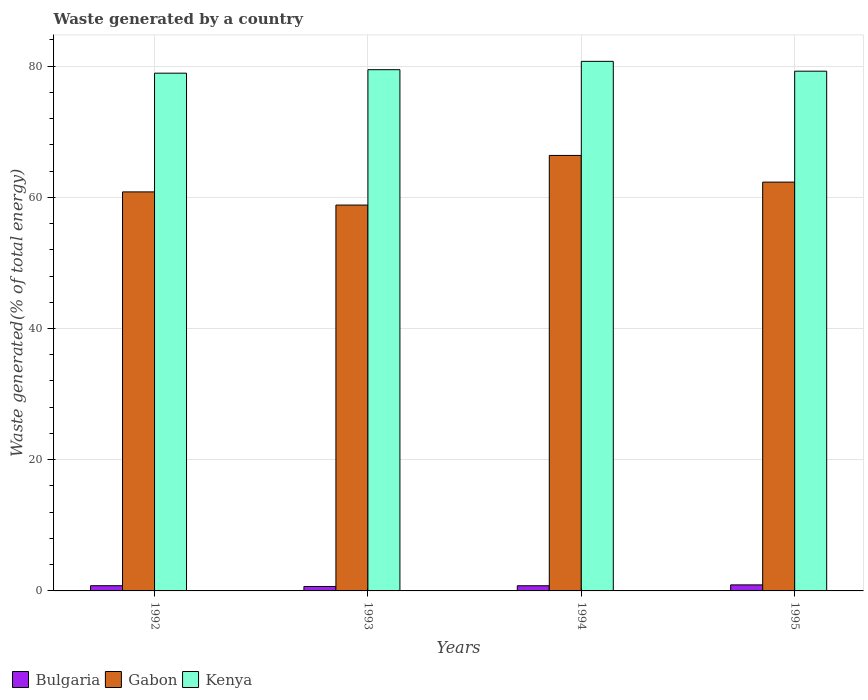How many groups of bars are there?
Provide a succinct answer. 4. Are the number of bars per tick equal to the number of legend labels?
Provide a succinct answer. Yes. How many bars are there on the 4th tick from the right?
Provide a succinct answer. 3. What is the label of the 4th group of bars from the left?
Your answer should be compact. 1995. In how many cases, is the number of bars for a given year not equal to the number of legend labels?
Ensure brevity in your answer.  0. What is the total waste generated in Kenya in 1995?
Offer a terse response. 79.23. Across all years, what is the maximum total waste generated in Gabon?
Give a very brief answer. 66.38. Across all years, what is the minimum total waste generated in Gabon?
Ensure brevity in your answer.  58.82. In which year was the total waste generated in Bulgaria maximum?
Provide a succinct answer. 1995. In which year was the total waste generated in Bulgaria minimum?
Give a very brief answer. 1993. What is the total total waste generated in Kenya in the graph?
Your answer should be compact. 318.33. What is the difference between the total waste generated in Kenya in 1993 and that in 1995?
Your answer should be compact. 0.23. What is the difference between the total waste generated in Gabon in 1992 and the total waste generated in Bulgaria in 1994?
Your response must be concise. 60.04. What is the average total waste generated in Kenya per year?
Provide a succinct answer. 79.58. In the year 1994, what is the difference between the total waste generated in Kenya and total waste generated in Bulgaria?
Offer a terse response. 79.94. What is the ratio of the total waste generated in Gabon in 1992 to that in 1994?
Offer a terse response. 0.92. Is the total waste generated in Kenya in 1993 less than that in 1994?
Offer a terse response. Yes. Is the difference between the total waste generated in Kenya in 1992 and 1994 greater than the difference between the total waste generated in Bulgaria in 1992 and 1994?
Your response must be concise. No. What is the difference between the highest and the second highest total waste generated in Kenya?
Ensure brevity in your answer.  1.27. What is the difference between the highest and the lowest total waste generated in Kenya?
Offer a terse response. 1.8. Is the sum of the total waste generated in Bulgaria in 1993 and 1995 greater than the maximum total waste generated in Kenya across all years?
Make the answer very short. No. What does the 2nd bar from the left in 1995 represents?
Offer a very short reply. Gabon. What does the 1st bar from the right in 1994 represents?
Ensure brevity in your answer.  Kenya. What is the difference between two consecutive major ticks on the Y-axis?
Ensure brevity in your answer.  20. Are the values on the major ticks of Y-axis written in scientific E-notation?
Your response must be concise. No. Does the graph contain any zero values?
Give a very brief answer. No. How are the legend labels stacked?
Your answer should be compact. Horizontal. What is the title of the graph?
Your answer should be very brief. Waste generated by a country. Does "Turkey" appear as one of the legend labels in the graph?
Make the answer very short. No. What is the label or title of the X-axis?
Provide a short and direct response. Years. What is the label or title of the Y-axis?
Offer a very short reply. Waste generated(% of total energy). What is the Waste generated(% of total energy) in Bulgaria in 1992?
Make the answer very short. 0.79. What is the Waste generated(% of total energy) in Gabon in 1992?
Provide a short and direct response. 60.83. What is the Waste generated(% of total energy) of Kenya in 1992?
Your answer should be very brief. 78.92. What is the Waste generated(% of total energy) of Bulgaria in 1993?
Make the answer very short. 0.68. What is the Waste generated(% of total energy) in Gabon in 1993?
Your response must be concise. 58.82. What is the Waste generated(% of total energy) of Kenya in 1993?
Your answer should be very brief. 79.45. What is the Waste generated(% of total energy) in Bulgaria in 1994?
Your answer should be compact. 0.79. What is the Waste generated(% of total energy) in Gabon in 1994?
Provide a short and direct response. 66.38. What is the Waste generated(% of total energy) in Kenya in 1994?
Ensure brevity in your answer.  80.73. What is the Waste generated(% of total energy) in Bulgaria in 1995?
Ensure brevity in your answer.  0.92. What is the Waste generated(% of total energy) of Gabon in 1995?
Offer a terse response. 62.32. What is the Waste generated(% of total energy) of Kenya in 1995?
Offer a very short reply. 79.23. Across all years, what is the maximum Waste generated(% of total energy) of Bulgaria?
Your response must be concise. 0.92. Across all years, what is the maximum Waste generated(% of total energy) in Gabon?
Offer a very short reply. 66.38. Across all years, what is the maximum Waste generated(% of total energy) of Kenya?
Offer a terse response. 80.73. Across all years, what is the minimum Waste generated(% of total energy) in Bulgaria?
Your answer should be compact. 0.68. Across all years, what is the minimum Waste generated(% of total energy) of Gabon?
Your answer should be compact. 58.82. Across all years, what is the minimum Waste generated(% of total energy) in Kenya?
Offer a very short reply. 78.92. What is the total Waste generated(% of total energy) of Bulgaria in the graph?
Make the answer very short. 3.18. What is the total Waste generated(% of total energy) in Gabon in the graph?
Offer a terse response. 248.34. What is the total Waste generated(% of total energy) in Kenya in the graph?
Ensure brevity in your answer.  318.33. What is the difference between the Waste generated(% of total energy) in Bulgaria in 1992 and that in 1993?
Your response must be concise. 0.12. What is the difference between the Waste generated(% of total energy) of Gabon in 1992 and that in 1993?
Your response must be concise. 2.01. What is the difference between the Waste generated(% of total energy) in Kenya in 1992 and that in 1993?
Offer a terse response. -0.53. What is the difference between the Waste generated(% of total energy) of Bulgaria in 1992 and that in 1994?
Provide a short and direct response. 0.01. What is the difference between the Waste generated(% of total energy) of Gabon in 1992 and that in 1994?
Your response must be concise. -5.56. What is the difference between the Waste generated(% of total energy) of Kenya in 1992 and that in 1994?
Provide a short and direct response. -1.8. What is the difference between the Waste generated(% of total energy) in Bulgaria in 1992 and that in 1995?
Offer a terse response. -0.13. What is the difference between the Waste generated(% of total energy) in Gabon in 1992 and that in 1995?
Make the answer very short. -1.49. What is the difference between the Waste generated(% of total energy) in Kenya in 1992 and that in 1995?
Provide a short and direct response. -0.3. What is the difference between the Waste generated(% of total energy) in Bulgaria in 1993 and that in 1994?
Keep it short and to the point. -0.11. What is the difference between the Waste generated(% of total energy) of Gabon in 1993 and that in 1994?
Keep it short and to the point. -7.57. What is the difference between the Waste generated(% of total energy) in Kenya in 1993 and that in 1994?
Keep it short and to the point. -1.27. What is the difference between the Waste generated(% of total energy) of Bulgaria in 1993 and that in 1995?
Ensure brevity in your answer.  -0.24. What is the difference between the Waste generated(% of total energy) in Gabon in 1993 and that in 1995?
Your response must be concise. -3.5. What is the difference between the Waste generated(% of total energy) of Kenya in 1993 and that in 1995?
Keep it short and to the point. 0.23. What is the difference between the Waste generated(% of total energy) of Bulgaria in 1994 and that in 1995?
Keep it short and to the point. -0.13. What is the difference between the Waste generated(% of total energy) in Gabon in 1994 and that in 1995?
Provide a short and direct response. 4.07. What is the difference between the Waste generated(% of total energy) in Kenya in 1994 and that in 1995?
Offer a very short reply. 1.5. What is the difference between the Waste generated(% of total energy) in Bulgaria in 1992 and the Waste generated(% of total energy) in Gabon in 1993?
Provide a succinct answer. -58.02. What is the difference between the Waste generated(% of total energy) in Bulgaria in 1992 and the Waste generated(% of total energy) in Kenya in 1993?
Ensure brevity in your answer.  -78.66. What is the difference between the Waste generated(% of total energy) in Gabon in 1992 and the Waste generated(% of total energy) in Kenya in 1993?
Provide a short and direct response. -18.63. What is the difference between the Waste generated(% of total energy) in Bulgaria in 1992 and the Waste generated(% of total energy) in Gabon in 1994?
Your answer should be compact. -65.59. What is the difference between the Waste generated(% of total energy) of Bulgaria in 1992 and the Waste generated(% of total energy) of Kenya in 1994?
Give a very brief answer. -79.93. What is the difference between the Waste generated(% of total energy) in Gabon in 1992 and the Waste generated(% of total energy) in Kenya in 1994?
Your answer should be compact. -19.9. What is the difference between the Waste generated(% of total energy) in Bulgaria in 1992 and the Waste generated(% of total energy) in Gabon in 1995?
Your answer should be compact. -61.52. What is the difference between the Waste generated(% of total energy) of Bulgaria in 1992 and the Waste generated(% of total energy) of Kenya in 1995?
Give a very brief answer. -78.43. What is the difference between the Waste generated(% of total energy) in Gabon in 1992 and the Waste generated(% of total energy) in Kenya in 1995?
Provide a succinct answer. -18.4. What is the difference between the Waste generated(% of total energy) of Bulgaria in 1993 and the Waste generated(% of total energy) of Gabon in 1994?
Your answer should be compact. -65.71. What is the difference between the Waste generated(% of total energy) of Bulgaria in 1993 and the Waste generated(% of total energy) of Kenya in 1994?
Provide a short and direct response. -80.05. What is the difference between the Waste generated(% of total energy) in Gabon in 1993 and the Waste generated(% of total energy) in Kenya in 1994?
Make the answer very short. -21.91. What is the difference between the Waste generated(% of total energy) of Bulgaria in 1993 and the Waste generated(% of total energy) of Gabon in 1995?
Give a very brief answer. -61.64. What is the difference between the Waste generated(% of total energy) in Bulgaria in 1993 and the Waste generated(% of total energy) in Kenya in 1995?
Keep it short and to the point. -78.55. What is the difference between the Waste generated(% of total energy) of Gabon in 1993 and the Waste generated(% of total energy) of Kenya in 1995?
Provide a succinct answer. -20.41. What is the difference between the Waste generated(% of total energy) in Bulgaria in 1994 and the Waste generated(% of total energy) in Gabon in 1995?
Your response must be concise. -61.53. What is the difference between the Waste generated(% of total energy) in Bulgaria in 1994 and the Waste generated(% of total energy) in Kenya in 1995?
Provide a succinct answer. -78.44. What is the difference between the Waste generated(% of total energy) of Gabon in 1994 and the Waste generated(% of total energy) of Kenya in 1995?
Provide a succinct answer. -12.84. What is the average Waste generated(% of total energy) in Bulgaria per year?
Your answer should be very brief. 0.79. What is the average Waste generated(% of total energy) of Gabon per year?
Your answer should be compact. 62.09. What is the average Waste generated(% of total energy) in Kenya per year?
Your answer should be very brief. 79.58. In the year 1992, what is the difference between the Waste generated(% of total energy) in Bulgaria and Waste generated(% of total energy) in Gabon?
Keep it short and to the point. -60.03. In the year 1992, what is the difference between the Waste generated(% of total energy) of Bulgaria and Waste generated(% of total energy) of Kenya?
Your answer should be very brief. -78.13. In the year 1992, what is the difference between the Waste generated(% of total energy) in Gabon and Waste generated(% of total energy) in Kenya?
Make the answer very short. -18.1. In the year 1993, what is the difference between the Waste generated(% of total energy) in Bulgaria and Waste generated(% of total energy) in Gabon?
Ensure brevity in your answer.  -58.14. In the year 1993, what is the difference between the Waste generated(% of total energy) in Bulgaria and Waste generated(% of total energy) in Kenya?
Give a very brief answer. -78.77. In the year 1993, what is the difference between the Waste generated(% of total energy) of Gabon and Waste generated(% of total energy) of Kenya?
Provide a succinct answer. -20.64. In the year 1994, what is the difference between the Waste generated(% of total energy) in Bulgaria and Waste generated(% of total energy) in Gabon?
Provide a succinct answer. -65.6. In the year 1994, what is the difference between the Waste generated(% of total energy) in Bulgaria and Waste generated(% of total energy) in Kenya?
Make the answer very short. -79.94. In the year 1994, what is the difference between the Waste generated(% of total energy) of Gabon and Waste generated(% of total energy) of Kenya?
Offer a very short reply. -14.34. In the year 1995, what is the difference between the Waste generated(% of total energy) of Bulgaria and Waste generated(% of total energy) of Gabon?
Your answer should be compact. -61.4. In the year 1995, what is the difference between the Waste generated(% of total energy) of Bulgaria and Waste generated(% of total energy) of Kenya?
Keep it short and to the point. -78.31. In the year 1995, what is the difference between the Waste generated(% of total energy) of Gabon and Waste generated(% of total energy) of Kenya?
Provide a succinct answer. -16.91. What is the ratio of the Waste generated(% of total energy) in Bulgaria in 1992 to that in 1993?
Offer a very short reply. 1.17. What is the ratio of the Waste generated(% of total energy) of Gabon in 1992 to that in 1993?
Keep it short and to the point. 1.03. What is the ratio of the Waste generated(% of total energy) of Kenya in 1992 to that in 1993?
Offer a terse response. 0.99. What is the ratio of the Waste generated(% of total energy) in Bulgaria in 1992 to that in 1994?
Your response must be concise. 1.01. What is the ratio of the Waste generated(% of total energy) of Gabon in 1992 to that in 1994?
Provide a short and direct response. 0.92. What is the ratio of the Waste generated(% of total energy) in Kenya in 1992 to that in 1994?
Keep it short and to the point. 0.98. What is the ratio of the Waste generated(% of total energy) in Bulgaria in 1992 to that in 1995?
Ensure brevity in your answer.  0.86. What is the ratio of the Waste generated(% of total energy) in Gabon in 1992 to that in 1995?
Your response must be concise. 0.98. What is the ratio of the Waste generated(% of total energy) of Bulgaria in 1993 to that in 1994?
Offer a terse response. 0.86. What is the ratio of the Waste generated(% of total energy) of Gabon in 1993 to that in 1994?
Give a very brief answer. 0.89. What is the ratio of the Waste generated(% of total energy) of Kenya in 1993 to that in 1994?
Offer a terse response. 0.98. What is the ratio of the Waste generated(% of total energy) of Bulgaria in 1993 to that in 1995?
Your answer should be very brief. 0.74. What is the ratio of the Waste generated(% of total energy) in Gabon in 1993 to that in 1995?
Your response must be concise. 0.94. What is the ratio of the Waste generated(% of total energy) of Bulgaria in 1994 to that in 1995?
Keep it short and to the point. 0.86. What is the ratio of the Waste generated(% of total energy) of Gabon in 1994 to that in 1995?
Keep it short and to the point. 1.07. What is the ratio of the Waste generated(% of total energy) of Kenya in 1994 to that in 1995?
Offer a terse response. 1.02. What is the difference between the highest and the second highest Waste generated(% of total energy) of Bulgaria?
Offer a terse response. 0.13. What is the difference between the highest and the second highest Waste generated(% of total energy) in Gabon?
Ensure brevity in your answer.  4.07. What is the difference between the highest and the second highest Waste generated(% of total energy) in Kenya?
Keep it short and to the point. 1.27. What is the difference between the highest and the lowest Waste generated(% of total energy) in Bulgaria?
Provide a short and direct response. 0.24. What is the difference between the highest and the lowest Waste generated(% of total energy) of Gabon?
Make the answer very short. 7.57. What is the difference between the highest and the lowest Waste generated(% of total energy) of Kenya?
Your answer should be very brief. 1.8. 